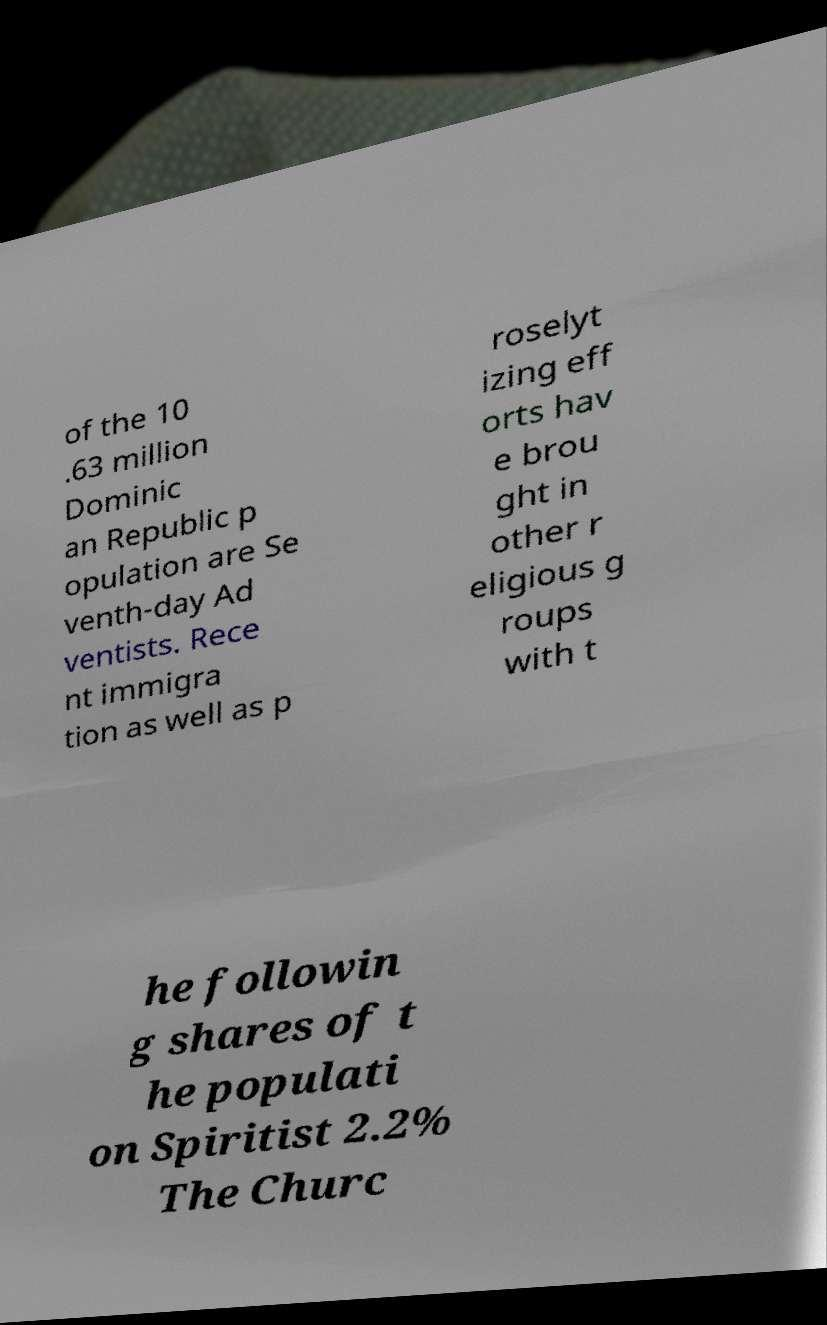Please read and relay the text visible in this image. What does it say? of the 10 .63 million Dominic an Republic p opulation are Se venth-day Ad ventists. Rece nt immigra tion as well as p roselyt izing eff orts hav e brou ght in other r eligious g roups with t he followin g shares of t he populati on Spiritist 2.2% The Churc 